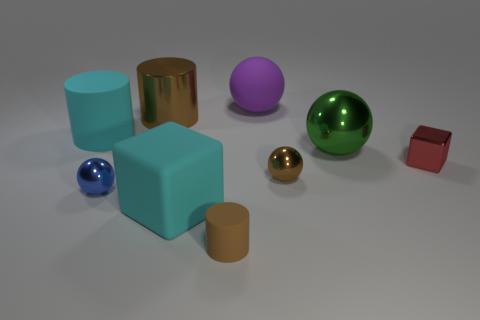Subtract all cyan balls. Subtract all brown blocks. How many balls are left? 4 Add 1 large green spheres. How many objects exist? 10 Subtract all cylinders. How many objects are left? 6 Subtract all large cyan rubber cubes. Subtract all big brown objects. How many objects are left? 7 Add 4 small brown matte cylinders. How many small brown matte cylinders are left? 5 Add 2 red objects. How many red objects exist? 3 Subtract 0 blue cylinders. How many objects are left? 9 